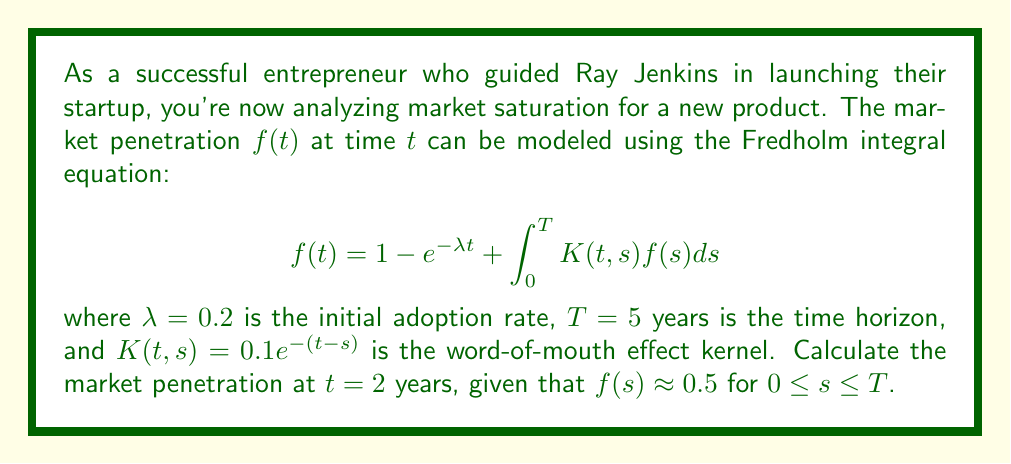Give your solution to this math problem. To solve this problem, we'll follow these steps:

1) First, we need to substitute the given values into the Fredholm integral equation:
   $$f(2) = 1 - e^{-0.2 \cdot 2} + \int_0^5 0.1e^{-(2-s)}f(s)ds$$

2) Calculate the first part of the equation:
   $$1 - e^{-0.2 \cdot 2} = 1 - e^{-0.4} \approx 0.3297$$

3) For the integral part, we're given that $f(s) \approx 0.5$ for all $s$ in the interval $[0,5]$. We can treat this as a constant and take it out of the integral:
   $$\int_0^5 0.1e^{-(2-s)}f(s)ds \approx 0.5 \cdot 0.1 \int_0^5 e^{-(2-s)}ds$$

4) Solve the integral:
   $$0.05 \int_0^5 e^{-(2-s)}ds = 0.05 [e^{s-2}]_0^5 = 0.05(e^3 - e^{-2}) \approx 1.0038$$

5) Sum up the parts:
   $$f(2) \approx 0.3297 + 1.0038 = 1.3335$$

6) However, since market penetration is typically expressed as a percentage or a fraction between 0 and 1, we need to cap this value at 1.
Answer: 1 (or 100% market penetration) 